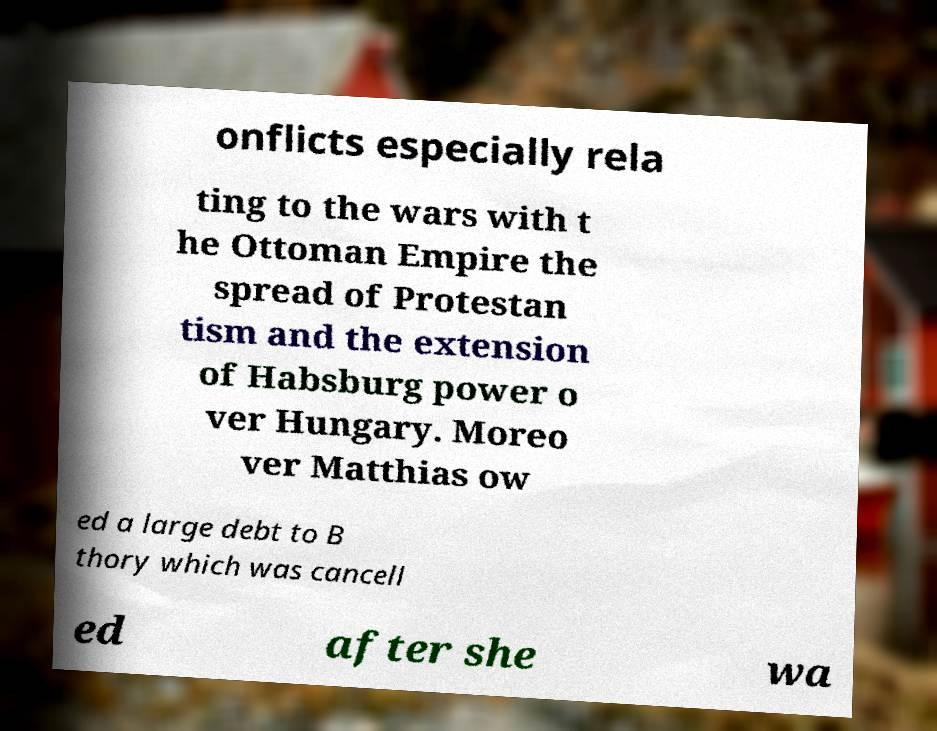Please read and relay the text visible in this image. What does it say? onflicts especially rela ting to the wars with t he Ottoman Empire the spread of Protestan tism and the extension of Habsburg power o ver Hungary. Moreo ver Matthias ow ed a large debt to B thory which was cancell ed after she wa 